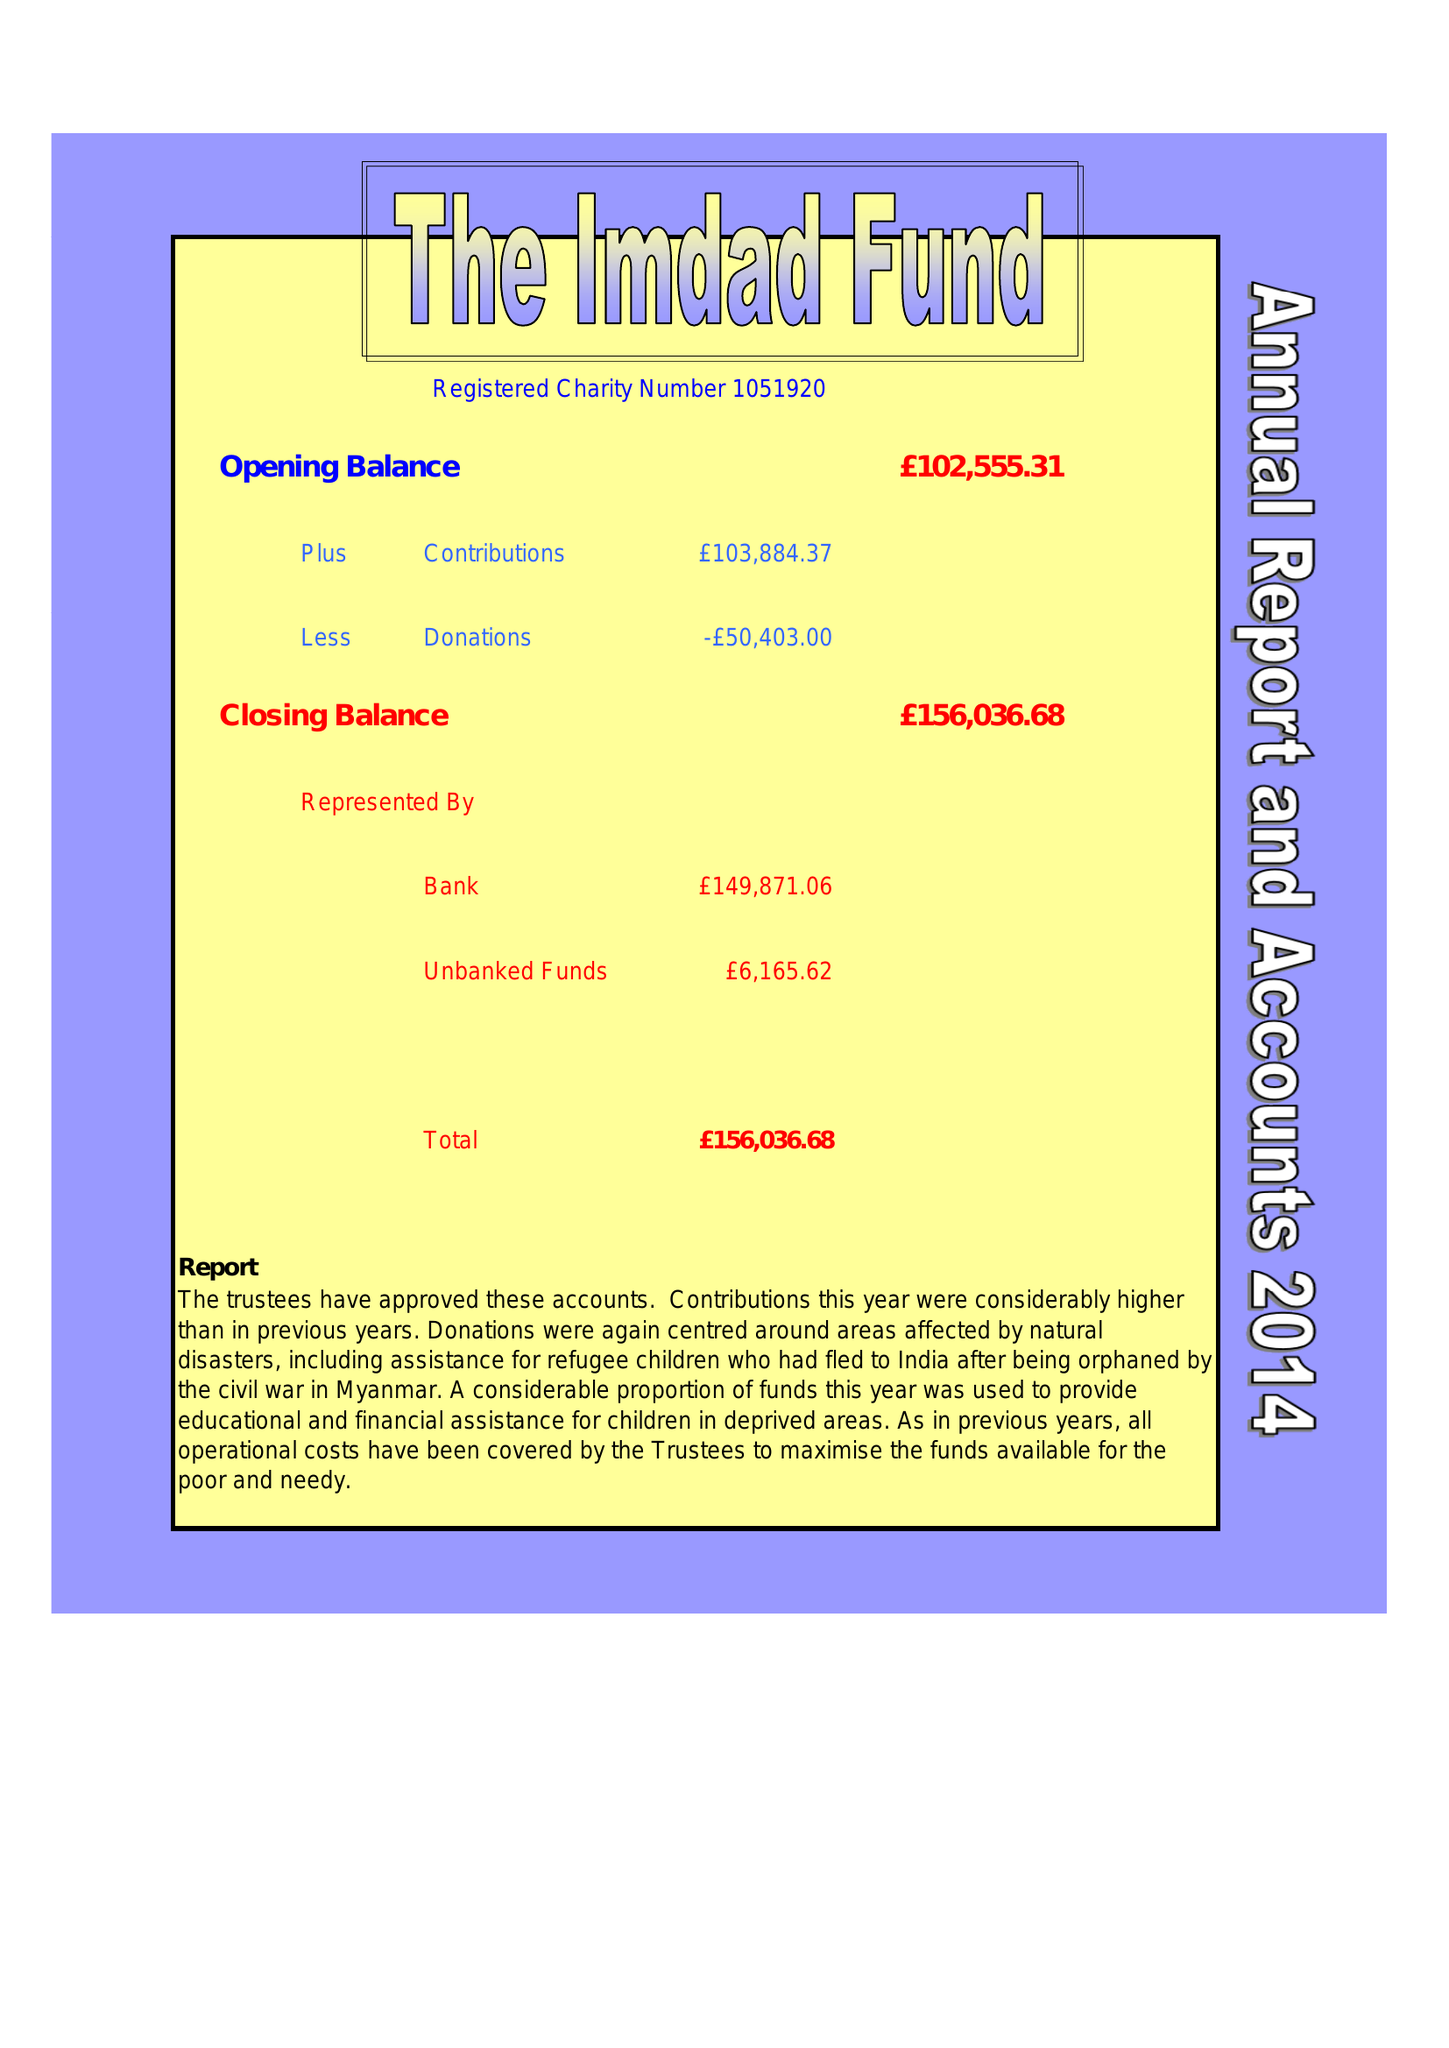What is the value for the spending_annually_in_british_pounds?
Answer the question using a single word or phrase. 50403.00 